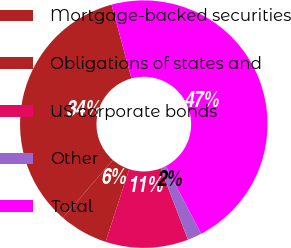<chart> <loc_0><loc_0><loc_500><loc_500><pie_chart><fcel>Mortgage-backed securities<fcel>Obligations of states and<fcel>US corporate bonds<fcel>Other<fcel>Total<nl><fcel>34.47%<fcel>6.34%<fcel>10.8%<fcel>1.87%<fcel>46.52%<nl></chart> 